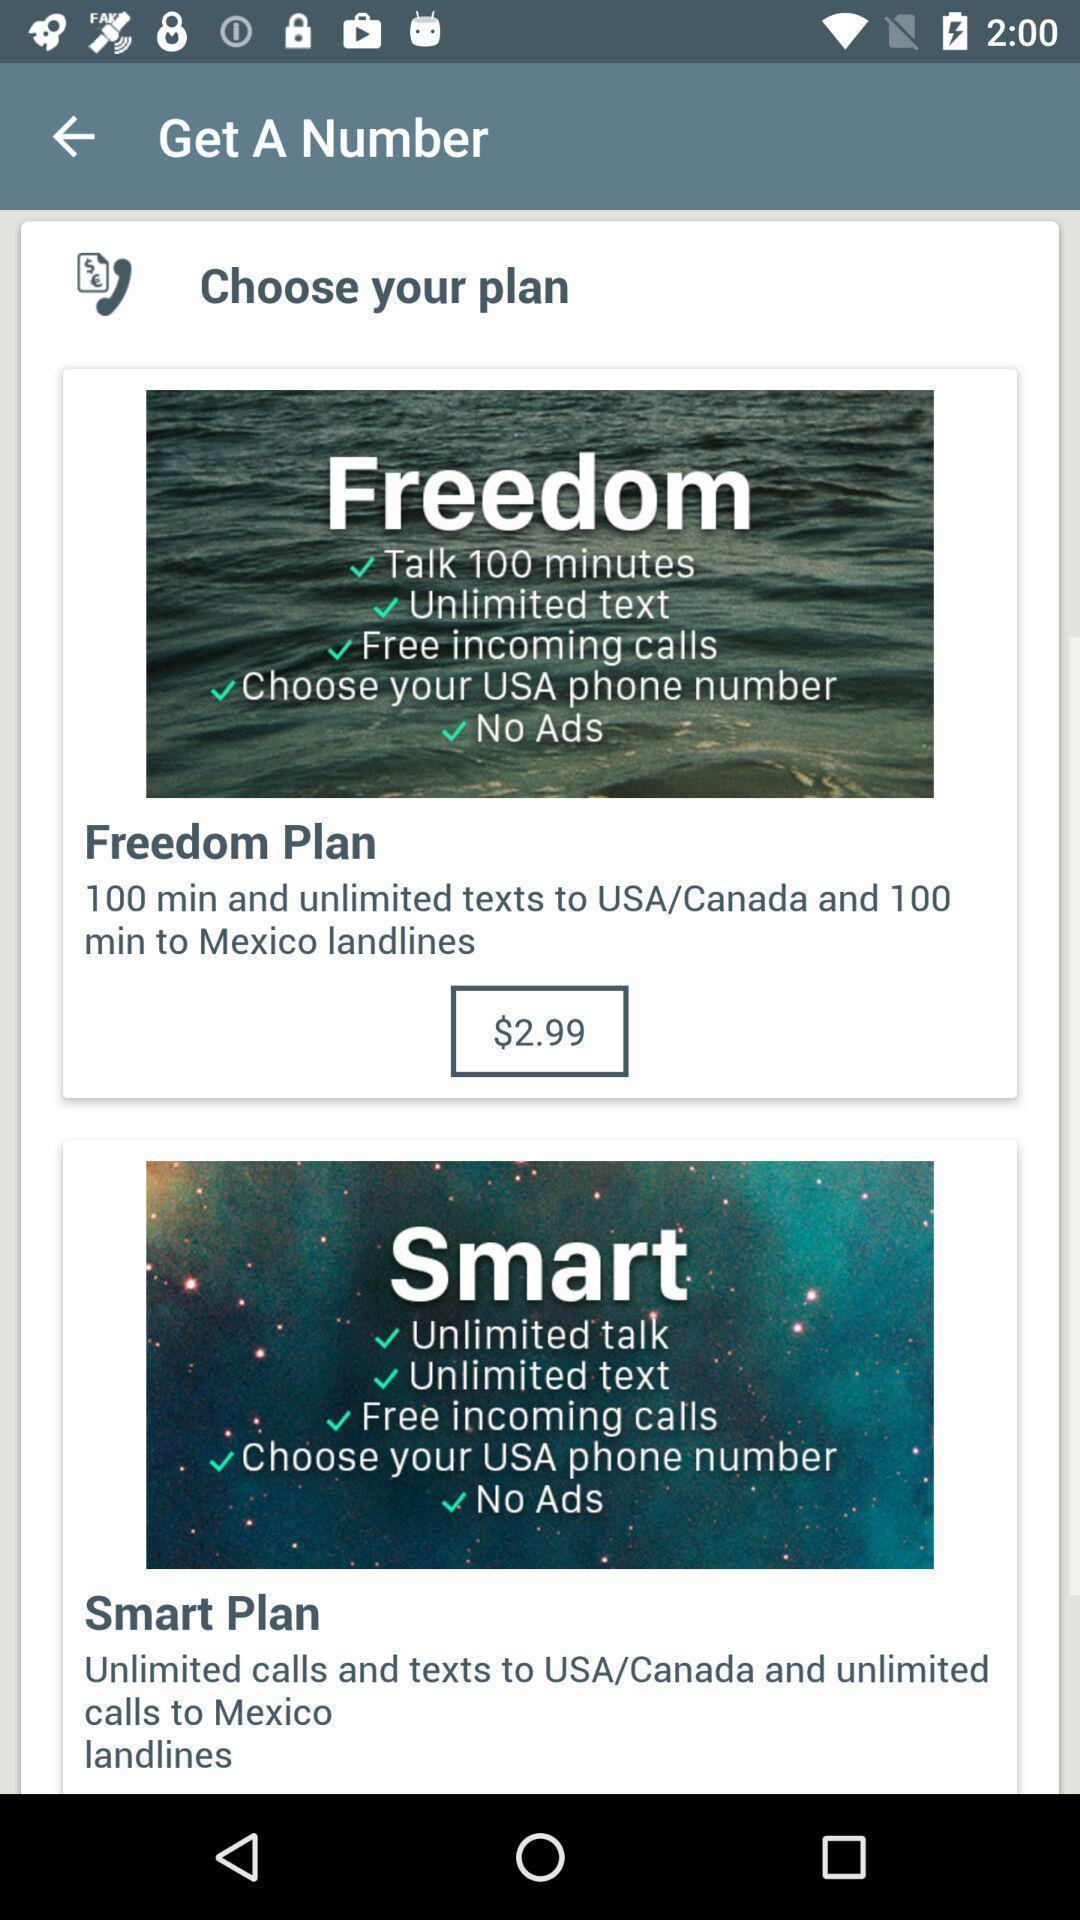Describe the content in this image. Various kinds of plans with prices in application. 